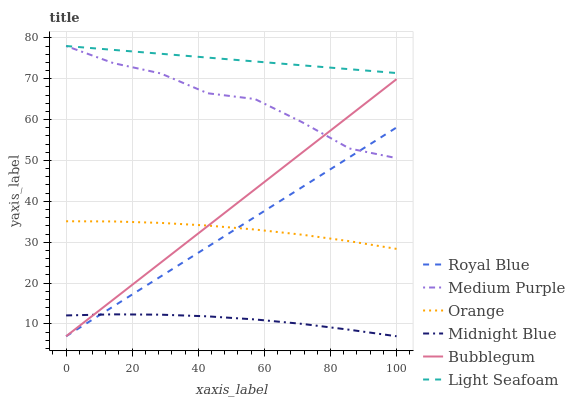Does Midnight Blue have the minimum area under the curve?
Answer yes or no. Yes. Does Light Seafoam have the maximum area under the curve?
Answer yes or no. Yes. Does Bubblegum have the minimum area under the curve?
Answer yes or no. No. Does Bubblegum have the maximum area under the curve?
Answer yes or no. No. Is Royal Blue the smoothest?
Answer yes or no. Yes. Is Medium Purple the roughest?
Answer yes or no. Yes. Is Bubblegum the smoothest?
Answer yes or no. No. Is Bubblegum the roughest?
Answer yes or no. No. Does Midnight Blue have the lowest value?
Answer yes or no. Yes. Does Medium Purple have the lowest value?
Answer yes or no. No. Does Light Seafoam have the highest value?
Answer yes or no. Yes. Does Bubblegum have the highest value?
Answer yes or no. No. Is Royal Blue less than Light Seafoam?
Answer yes or no. Yes. Is Light Seafoam greater than Orange?
Answer yes or no. Yes. Does Orange intersect Royal Blue?
Answer yes or no. Yes. Is Orange less than Royal Blue?
Answer yes or no. No. Is Orange greater than Royal Blue?
Answer yes or no. No. Does Royal Blue intersect Light Seafoam?
Answer yes or no. No. 